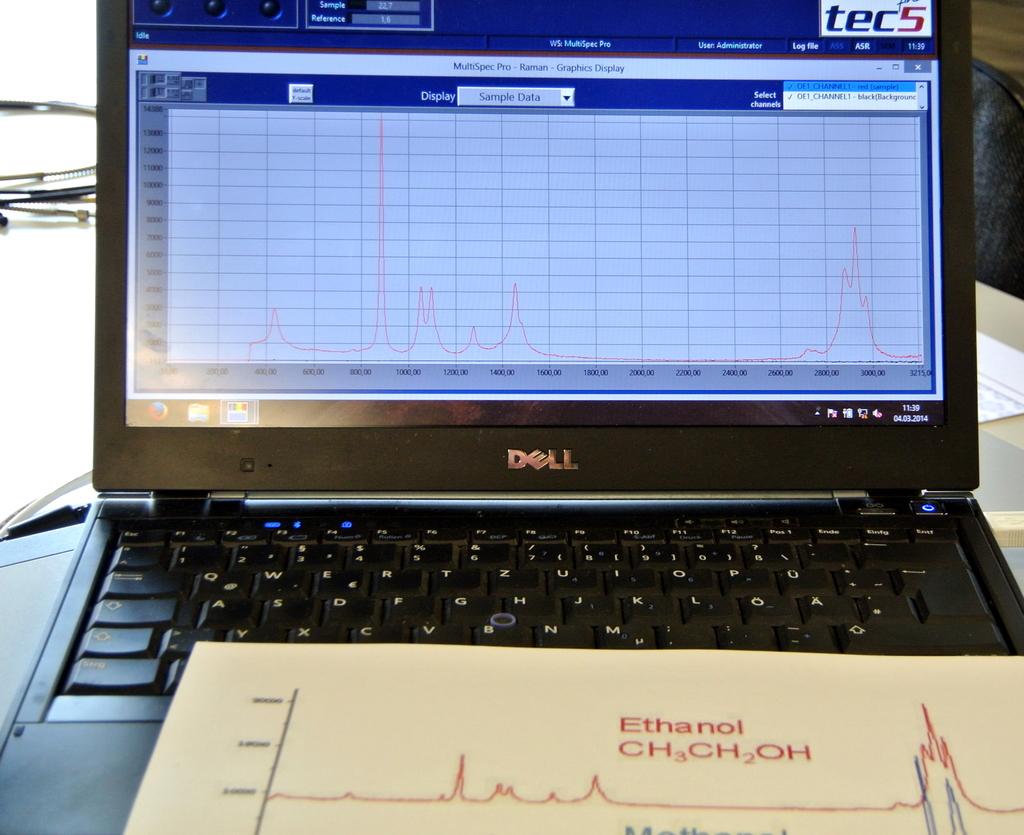What brand is this laptop?
Offer a terse response. Dell. What is the chemical code on the bottom in red?
Keep it short and to the point. Ch3ch2oh. 